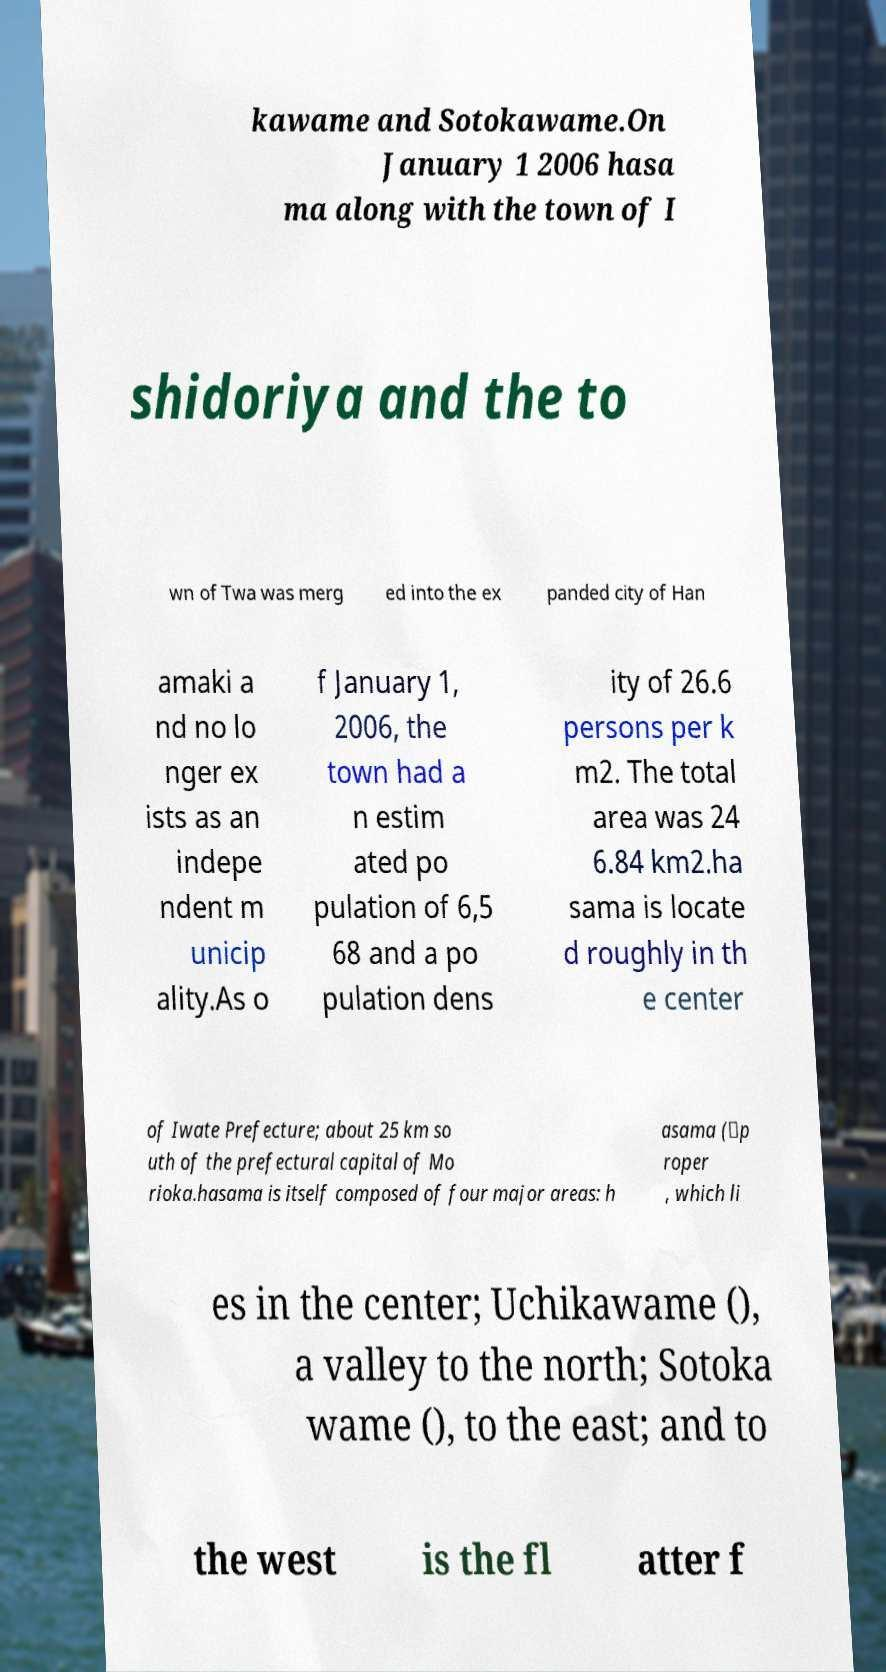Can you read and provide the text displayed in the image?This photo seems to have some interesting text. Can you extract and type it out for me? kawame and Sotokawame.On January 1 2006 hasa ma along with the town of I shidoriya and the to wn of Twa was merg ed into the ex panded city of Han amaki a nd no lo nger ex ists as an indepe ndent m unicip ality.As o f January 1, 2006, the town had a n estim ated po pulation of 6,5 68 and a po pulation dens ity of 26.6 persons per k m2. The total area was 24 6.84 km2.ha sama is locate d roughly in th e center of Iwate Prefecture; about 25 km so uth of the prefectural capital of Mo rioka.hasama is itself composed of four major areas: h asama (）p roper , which li es in the center; Uchikawame (), a valley to the north; Sotoka wame (), to the east; and to the west is the fl atter f 